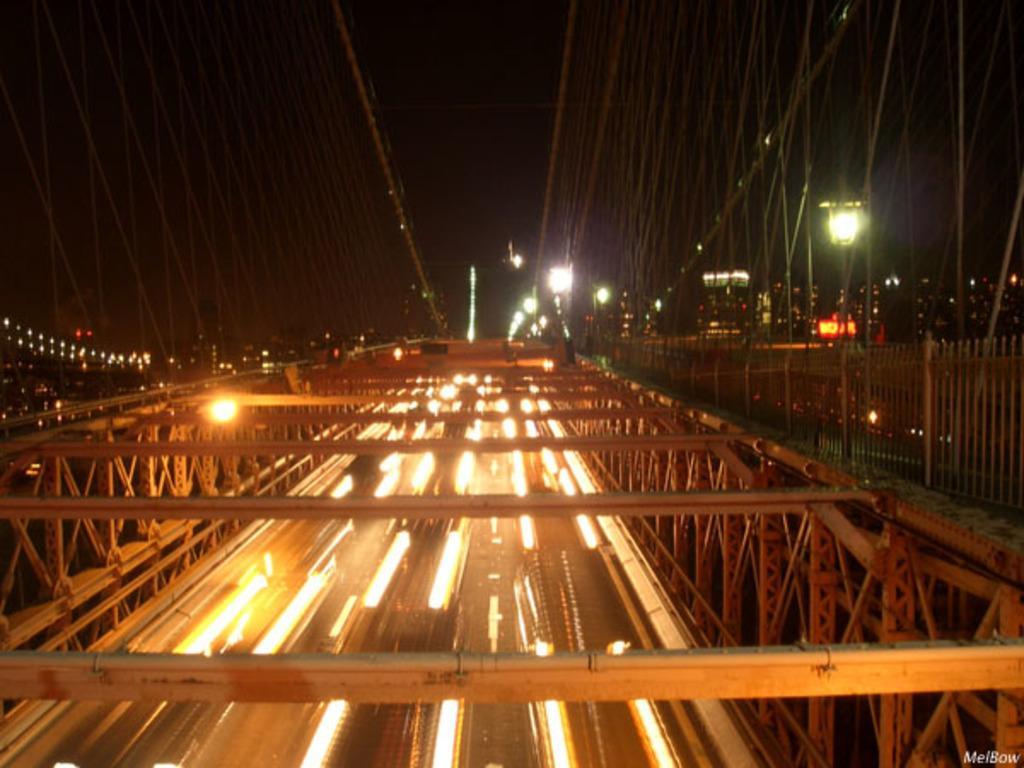How would you summarize this image in a sentence or two? In the picture we can see the bridge with roads and lights and the bridge is covered with railing around it and top of it, we can see some wires to it and in the background we can see some lights in the dark. 